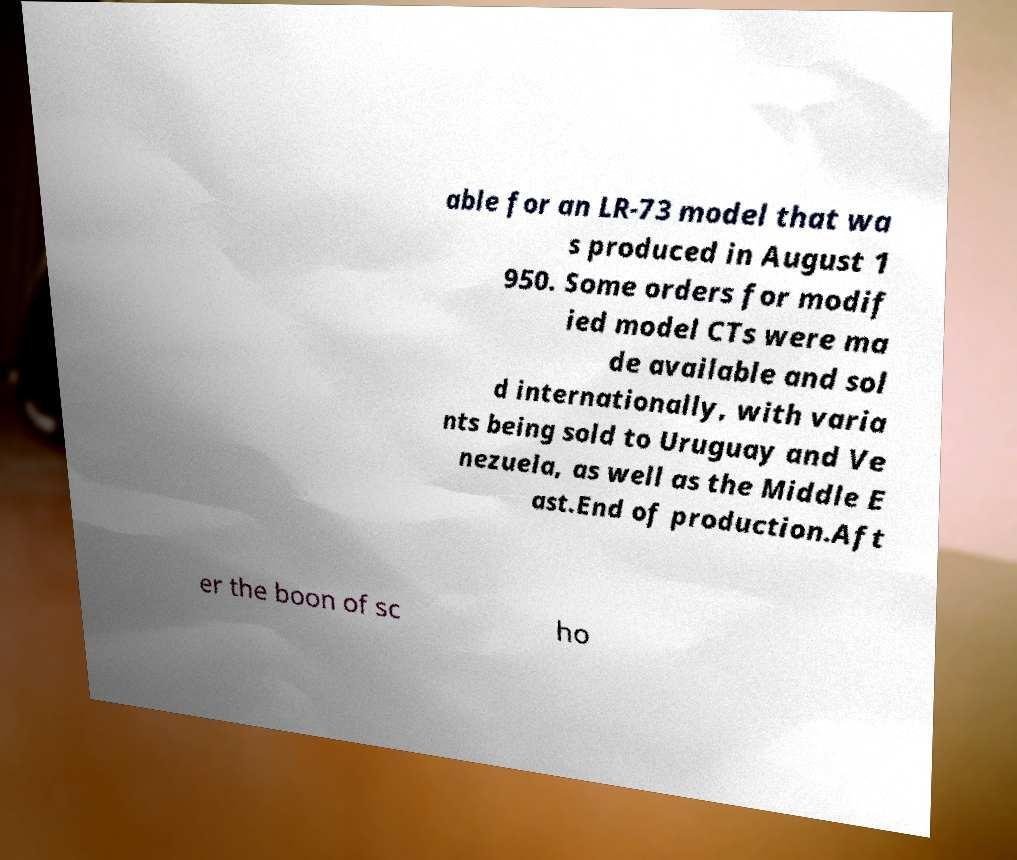Please read and relay the text visible in this image. What does it say? able for an LR-73 model that wa s produced in August 1 950. Some orders for modif ied model CTs were ma de available and sol d internationally, with varia nts being sold to Uruguay and Ve nezuela, as well as the Middle E ast.End of production.Aft er the boon of sc ho 